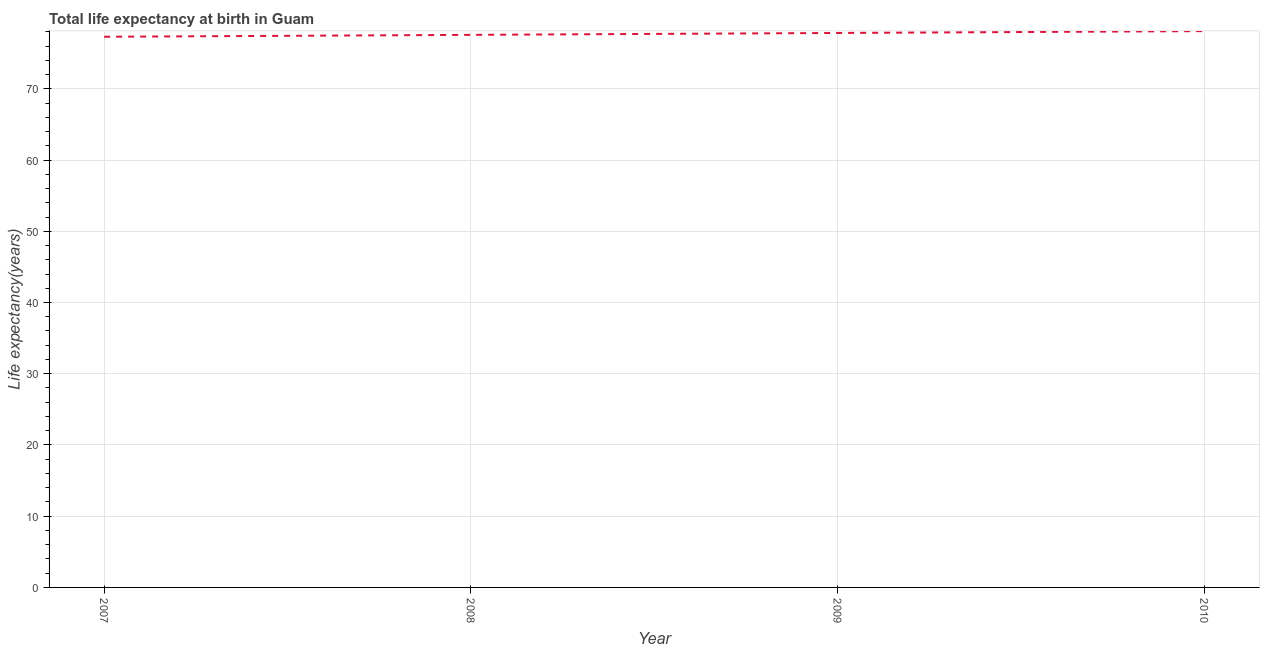What is the life expectancy at birth in 2008?
Give a very brief answer. 77.58. Across all years, what is the maximum life expectancy at birth?
Offer a terse response. 78.1. Across all years, what is the minimum life expectancy at birth?
Your response must be concise. 77.31. In which year was the life expectancy at birth maximum?
Your response must be concise. 2010. What is the sum of the life expectancy at birth?
Keep it short and to the point. 310.82. What is the difference between the life expectancy at birth in 2007 and 2008?
Give a very brief answer. -0.27. What is the average life expectancy at birth per year?
Offer a very short reply. 77.71. What is the median life expectancy at birth?
Provide a short and direct response. 77.71. In how many years, is the life expectancy at birth greater than 48 years?
Provide a short and direct response. 4. Do a majority of the years between 2009 and 2010 (inclusive) have life expectancy at birth greater than 36 years?
Your answer should be compact. Yes. What is the ratio of the life expectancy at birth in 2008 to that in 2009?
Your answer should be very brief. 1. Is the life expectancy at birth in 2008 less than that in 2010?
Offer a terse response. Yes. What is the difference between the highest and the second highest life expectancy at birth?
Keep it short and to the point. 0.26. Is the sum of the life expectancy at birth in 2007 and 2009 greater than the maximum life expectancy at birth across all years?
Your answer should be compact. Yes. What is the difference between the highest and the lowest life expectancy at birth?
Provide a succinct answer. 0.79. In how many years, is the life expectancy at birth greater than the average life expectancy at birth taken over all years?
Ensure brevity in your answer.  2. Does the life expectancy at birth monotonically increase over the years?
Keep it short and to the point. Yes. How many lines are there?
Provide a short and direct response. 1. What is the difference between two consecutive major ticks on the Y-axis?
Offer a very short reply. 10. Are the values on the major ticks of Y-axis written in scientific E-notation?
Provide a short and direct response. No. Does the graph contain any zero values?
Offer a terse response. No. What is the title of the graph?
Provide a short and direct response. Total life expectancy at birth in Guam. What is the label or title of the X-axis?
Offer a terse response. Year. What is the label or title of the Y-axis?
Your answer should be compact. Life expectancy(years). What is the Life expectancy(years) in 2007?
Keep it short and to the point. 77.31. What is the Life expectancy(years) in 2008?
Your answer should be very brief. 77.58. What is the Life expectancy(years) in 2009?
Offer a very short reply. 77.84. What is the Life expectancy(years) of 2010?
Give a very brief answer. 78.1. What is the difference between the Life expectancy(years) in 2007 and 2008?
Keep it short and to the point. -0.27. What is the difference between the Life expectancy(years) in 2007 and 2009?
Your response must be concise. -0.53. What is the difference between the Life expectancy(years) in 2007 and 2010?
Make the answer very short. -0.79. What is the difference between the Life expectancy(years) in 2008 and 2009?
Ensure brevity in your answer.  -0.26. What is the difference between the Life expectancy(years) in 2008 and 2010?
Offer a terse response. -0.53. What is the difference between the Life expectancy(years) in 2009 and 2010?
Give a very brief answer. -0.26. What is the ratio of the Life expectancy(years) in 2007 to that in 2008?
Give a very brief answer. 1. What is the ratio of the Life expectancy(years) in 2007 to that in 2009?
Your answer should be very brief. 0.99. What is the ratio of the Life expectancy(years) in 2007 to that in 2010?
Make the answer very short. 0.99. What is the ratio of the Life expectancy(years) in 2008 to that in 2010?
Provide a short and direct response. 0.99. What is the ratio of the Life expectancy(years) in 2009 to that in 2010?
Keep it short and to the point. 1. 